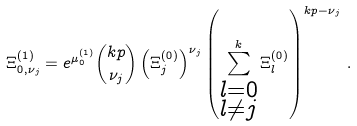<formula> <loc_0><loc_0><loc_500><loc_500>\Xi _ { 0 , \nu _ { j } } ^ { ( 1 ) } = e ^ { \mu _ { 0 } ^ { ( 1 ) } } { k p \choose \nu _ { j } } \left ( \Xi _ { j } ^ { ( 0 ) } \right ) ^ { \nu _ { j } } \left ( \sum _ { \substack { l = 0 \\ l \neq j } } ^ { k } \Xi _ { l } ^ { ( 0 ) } \right ) ^ { k p - \nu _ { j } } \, .</formula> 